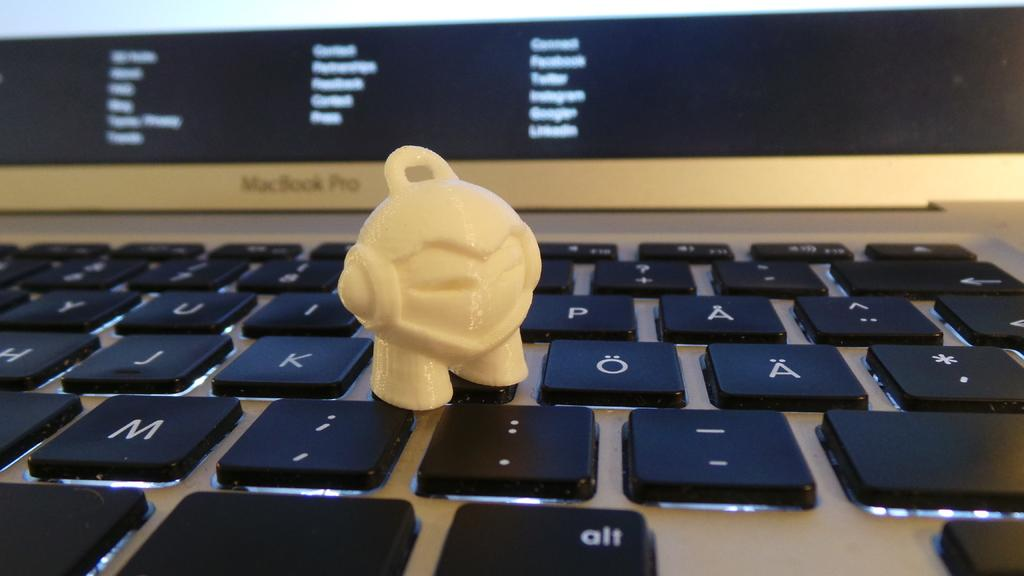<image>
Share a concise interpretation of the image provided. A small white character has been placed on top of a MacBook Pro keyboard. 